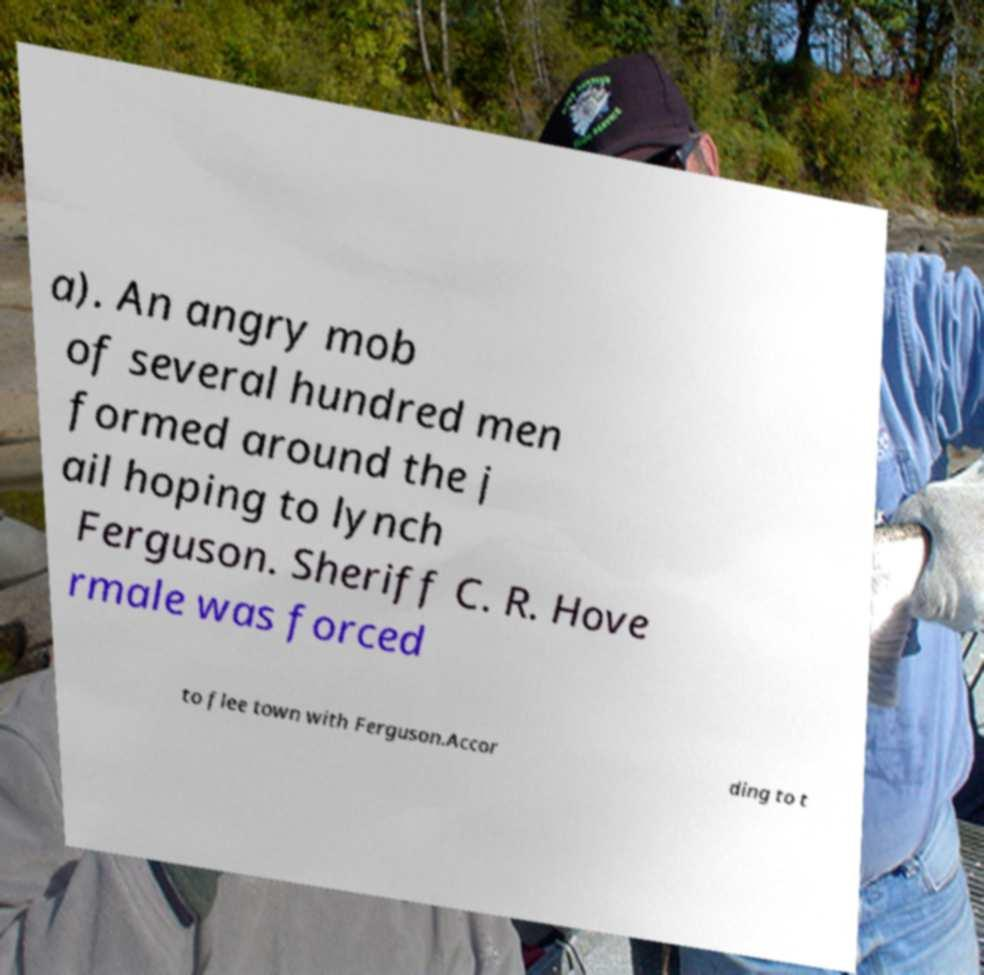Could you extract and type out the text from this image? a). An angry mob of several hundred men formed around the j ail hoping to lynch Ferguson. Sheriff C. R. Hove rmale was forced to flee town with Ferguson.Accor ding to t 